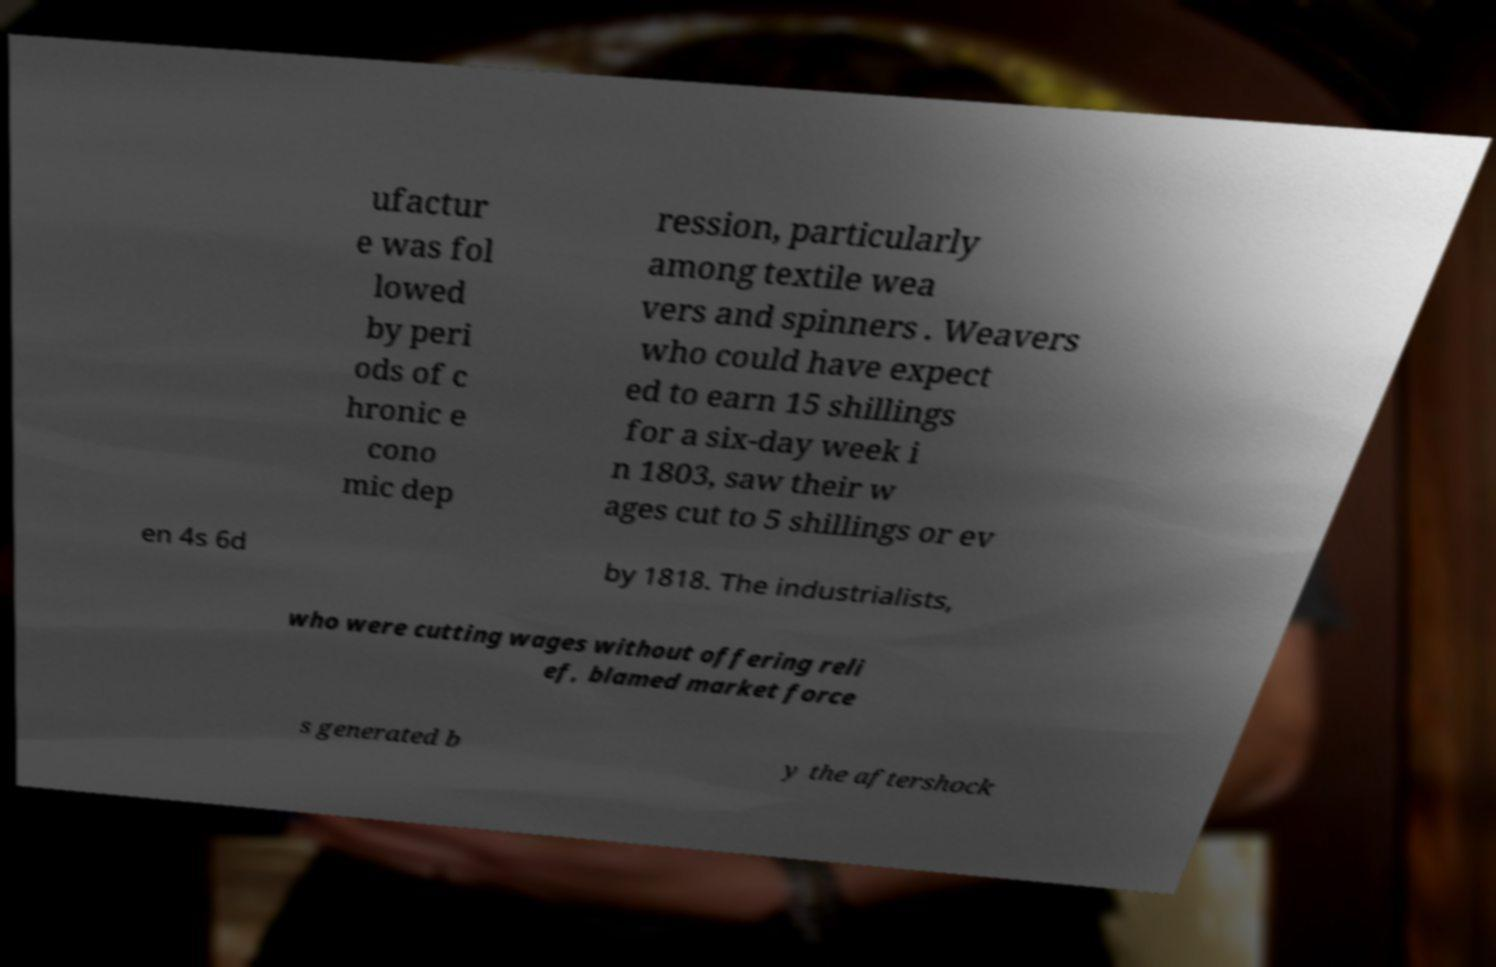Can you accurately transcribe the text from the provided image for me? ufactur e was fol lowed by peri ods of c hronic e cono mic dep ression, particularly among textile wea vers and spinners . Weavers who could have expect ed to earn 15 shillings for a six-day week i n 1803, saw their w ages cut to 5 shillings or ev en 4s 6d by 1818. The industrialists, who were cutting wages without offering reli ef, blamed market force s generated b y the aftershock 